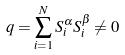<formula> <loc_0><loc_0><loc_500><loc_500>q = \sum _ { i = 1 } ^ { N } S _ { i } ^ { \alpha } S _ { i } ^ { \beta } \ne 0</formula> 